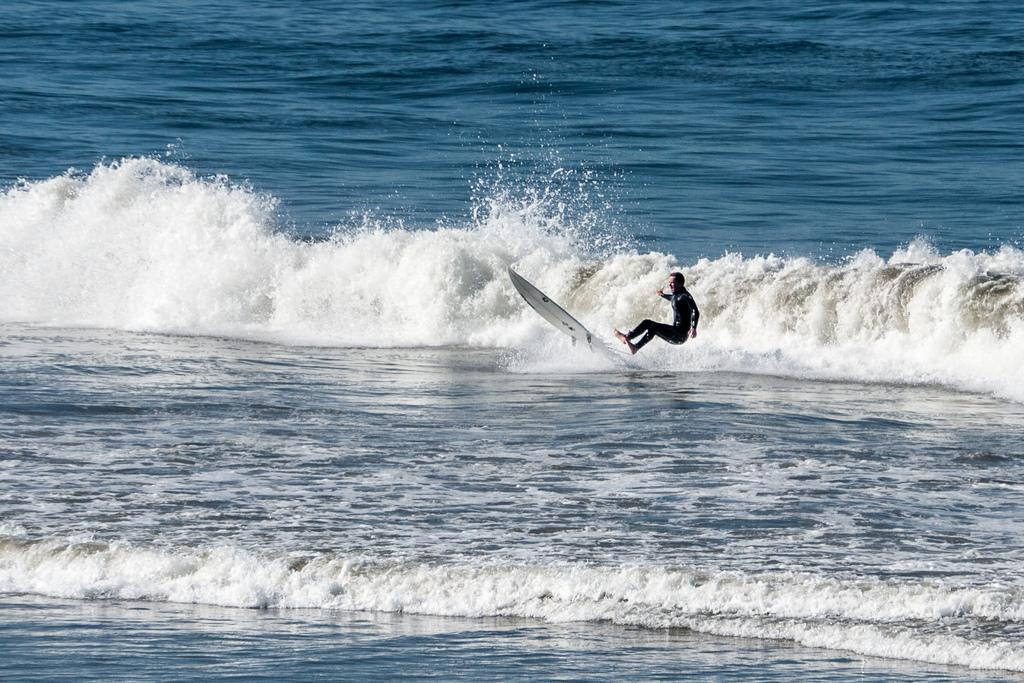What is the main subject of the image? The main subject of the image is a man. What is the man doing in the image? The man is surfing on the water. What color clothes is the man wearing? The man is wearing black color clothes. What type of account does the goat have in the image? There is no goat present in the image, so it is not possible to determine if a goat has an account or not. 